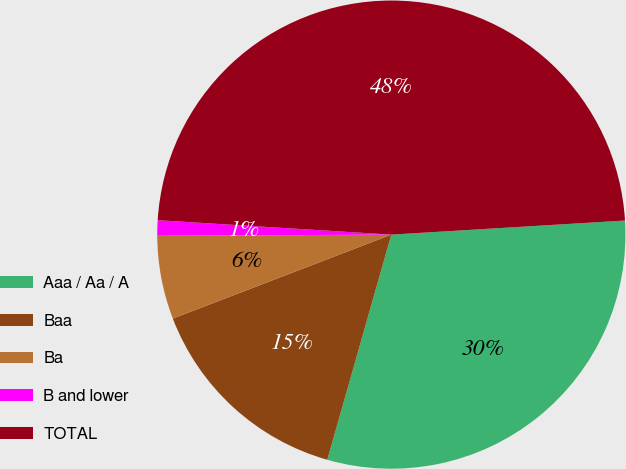<chart> <loc_0><loc_0><loc_500><loc_500><pie_chart><fcel>Aaa / Aa / A<fcel>Baa<fcel>Ba<fcel>B and lower<fcel>TOTAL<nl><fcel>30.37%<fcel>14.75%<fcel>5.76%<fcel>1.06%<fcel>48.06%<nl></chart> 